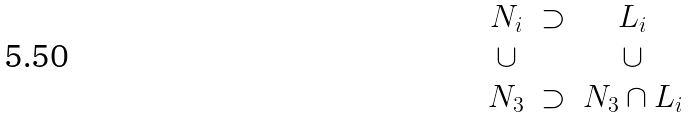<formula> <loc_0><loc_0><loc_500><loc_500>\begin{matrix} N _ { i } & \supset & L _ { i } \\ \cup & & \cup \\ N _ { 3 } & \supset & N _ { 3 } \cap L _ { i } \end{matrix}</formula> 